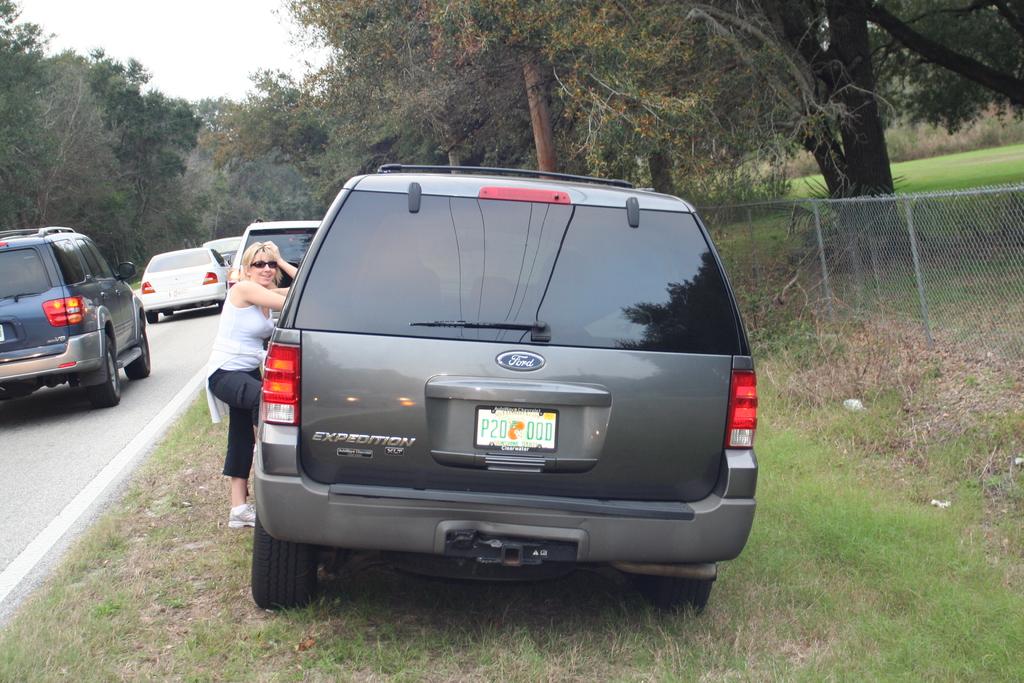What does the car's license plate read as?
Your response must be concise. P20 000. 